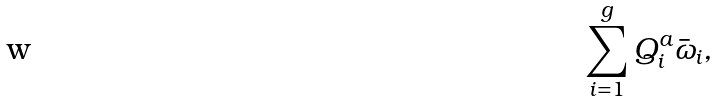<formula> <loc_0><loc_0><loc_500><loc_500>\sum _ { i = 1 } ^ { g } Q _ { i } ^ { a } \bar { \omega } _ { i } ,</formula> 